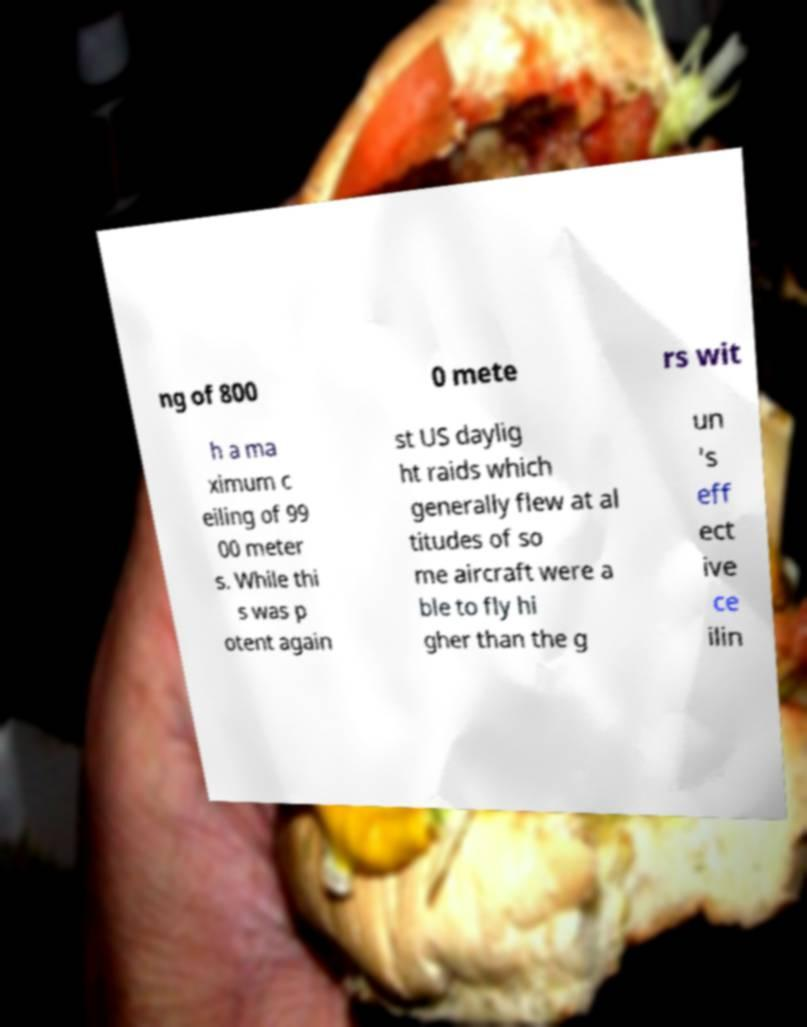There's text embedded in this image that I need extracted. Can you transcribe it verbatim? ng of 800 0 mete rs wit h a ma ximum c eiling of 99 00 meter s. While thi s was p otent again st US daylig ht raids which generally flew at al titudes of so me aircraft were a ble to fly hi gher than the g un 's eff ect ive ce ilin 